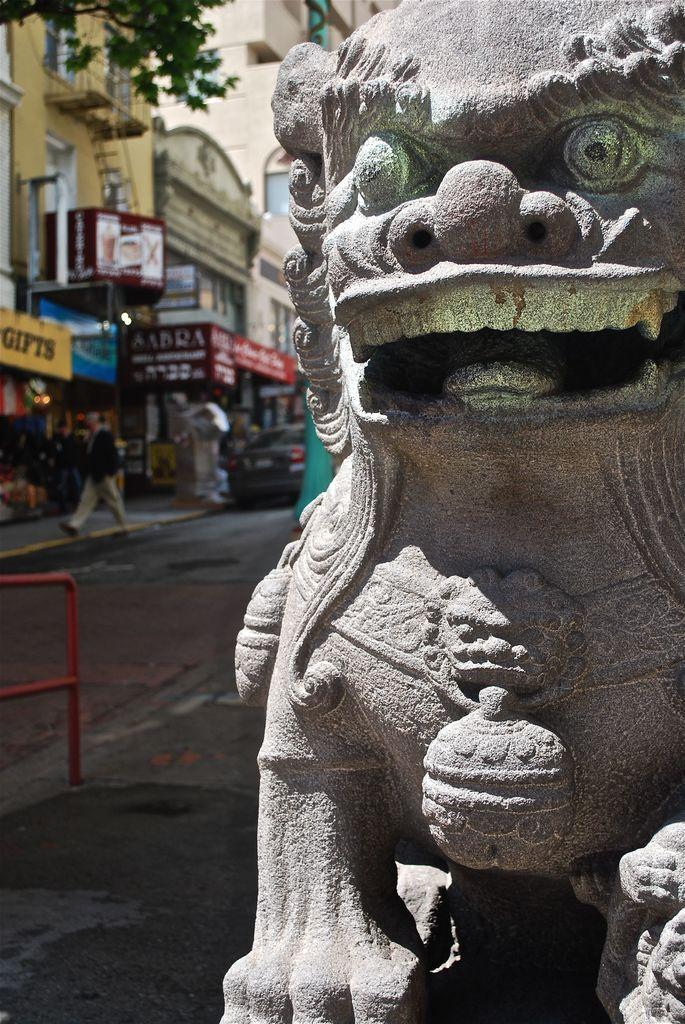What is located on the right side of the image? There is a statue on the right side of the image. What can be seen on the left side of the image? Buildings, boards, a ladder, people, walls, a vehicle, and rods are visible on the left side of the image. What type of pathways are present in the image? There are roads on the left side of the image. What type of disgust can be seen on the statue's face in the image? There is no indication of disgust on the statue's face in the image, as the statue's expression is not described in the provided facts. Can you tell me how many porters are present in the image? There is no mention of porters in the provided facts, so it cannot be determined from the image. 